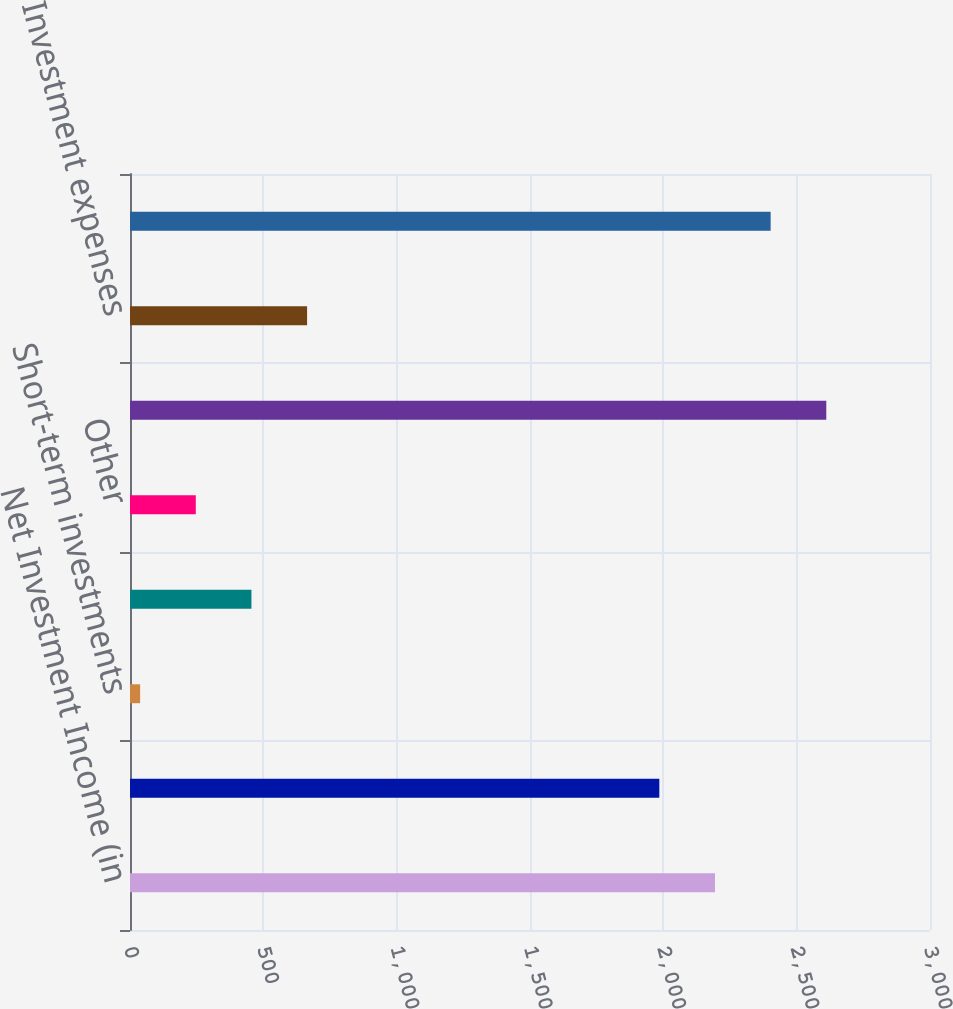<chart> <loc_0><loc_0><loc_500><loc_500><bar_chart><fcel>Net Investment Income (in<fcel>Fixed maturities<fcel>Short-term investments<fcel>Equity securities<fcel>Other<fcel>Gross investment income<fcel>Investment expenses<fcel>Net investment income<nl><fcel>2193.7<fcel>1985<fcel>38<fcel>455.4<fcel>246.7<fcel>2611.1<fcel>664.1<fcel>2402.4<nl></chart> 